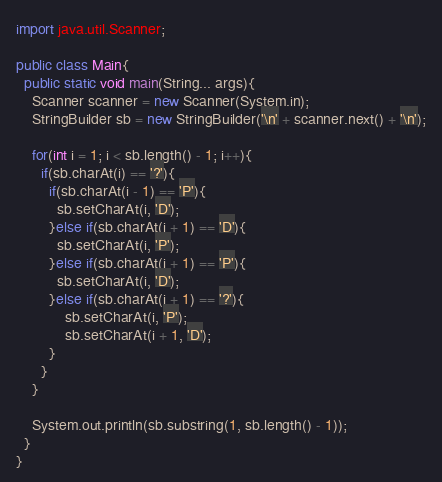<code> <loc_0><loc_0><loc_500><loc_500><_Java_>import java.util.Scanner;

public class Main{
  public static void main(String... args){
    Scanner scanner = new Scanner(System.in);
    StringBuilder sb = new StringBuilder('\n' + scanner.next() + '\n');

    for(int i = 1; i < sb.length() - 1; i++){
      if(sb.charAt(i) == '?'){
        if(sb.charAt(i - 1) == 'P'){
          sb.setCharAt(i, 'D');
        }else if(sb.charAt(i + 1) == 'D'){
          sb.setCharAt(i, 'P');
        }else if(sb.charAt(i + 1) == 'P'){
          sb.setCharAt(i, 'D');
        }else if(sb.charAt(i + 1) == '?'){
            sb.setCharAt(i, 'P');
            sb.setCharAt(i + 1, 'D');
        }
      }
    }
        
    System.out.println(sb.substring(1, sb.length() - 1));
  }
}</code> 